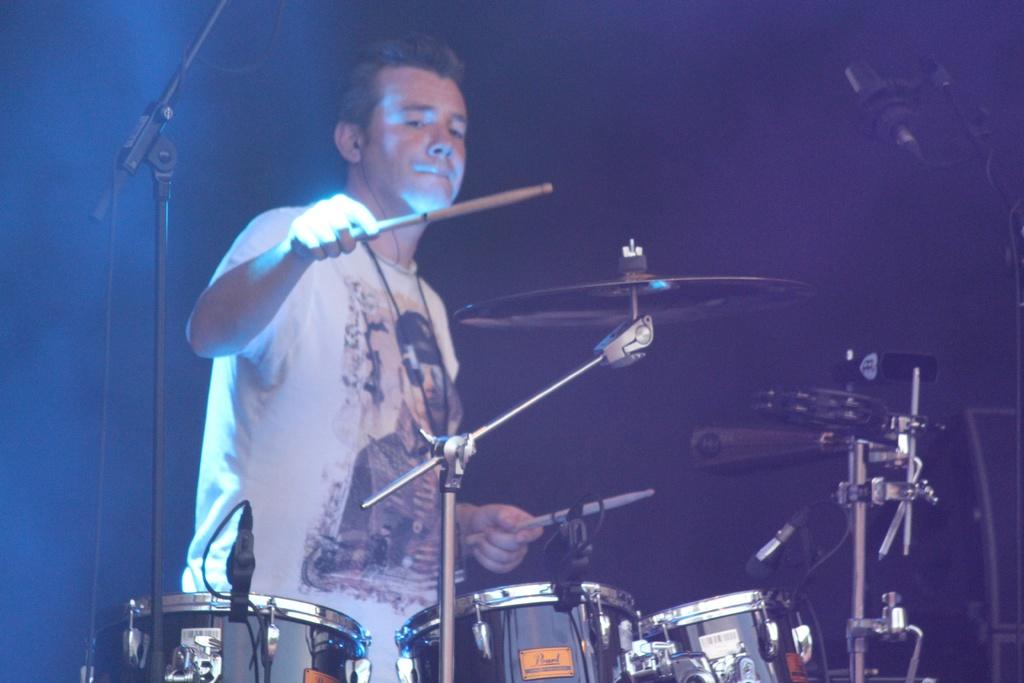Who is the main subject in the image? There is a man in the image. What is the man wearing? The man is wearing a white t-shirt. What is the man doing in the image? The man is playing a drum. What type of event might be taking place in the image? The setting appears to be a concert. What type of joke is the actor telling on the swing in the image? There is no actor or swing present in the image; it features a man playing a drum in a concert setting. 